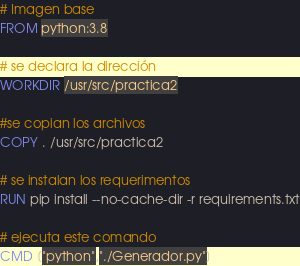<code> <loc_0><loc_0><loc_500><loc_500><_Dockerfile_># Imagen base
FROM python:3.8

# se declara la dirección
WORKDIR /usr/src/practica2

#se copian los archivos
COPY . /usr/src/practica2

# se instalan los requerimentos
RUN pip install --no-cache-dir -r requirements.txt

# ejecuta este comando
CMD ["python","./Generador.py"]
</code> 